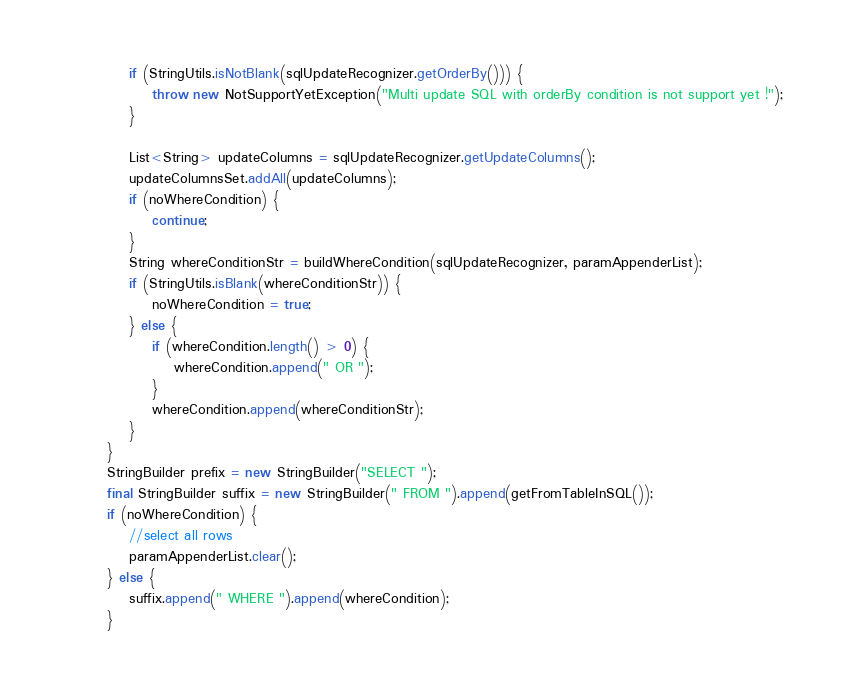<code> <loc_0><loc_0><loc_500><loc_500><_Java_>            if (StringUtils.isNotBlank(sqlUpdateRecognizer.getOrderBy())) {
                throw new NotSupportYetException("Multi update SQL with orderBy condition is not support yet !");
            }

            List<String> updateColumns = sqlUpdateRecognizer.getUpdateColumns();
            updateColumnsSet.addAll(updateColumns);
            if (noWhereCondition) {
                continue;
            }
            String whereConditionStr = buildWhereCondition(sqlUpdateRecognizer, paramAppenderList);
            if (StringUtils.isBlank(whereConditionStr)) {
                noWhereCondition = true;
            } else {
                if (whereCondition.length() > 0) {
                    whereCondition.append(" OR ");
                }
                whereCondition.append(whereConditionStr);
            }
        }
        StringBuilder prefix = new StringBuilder("SELECT ");
        final StringBuilder suffix = new StringBuilder(" FROM ").append(getFromTableInSQL());
        if (noWhereCondition) {
            //select all rows
            paramAppenderList.clear();
        } else {
            suffix.append(" WHERE ").append(whereCondition);
        }</code> 